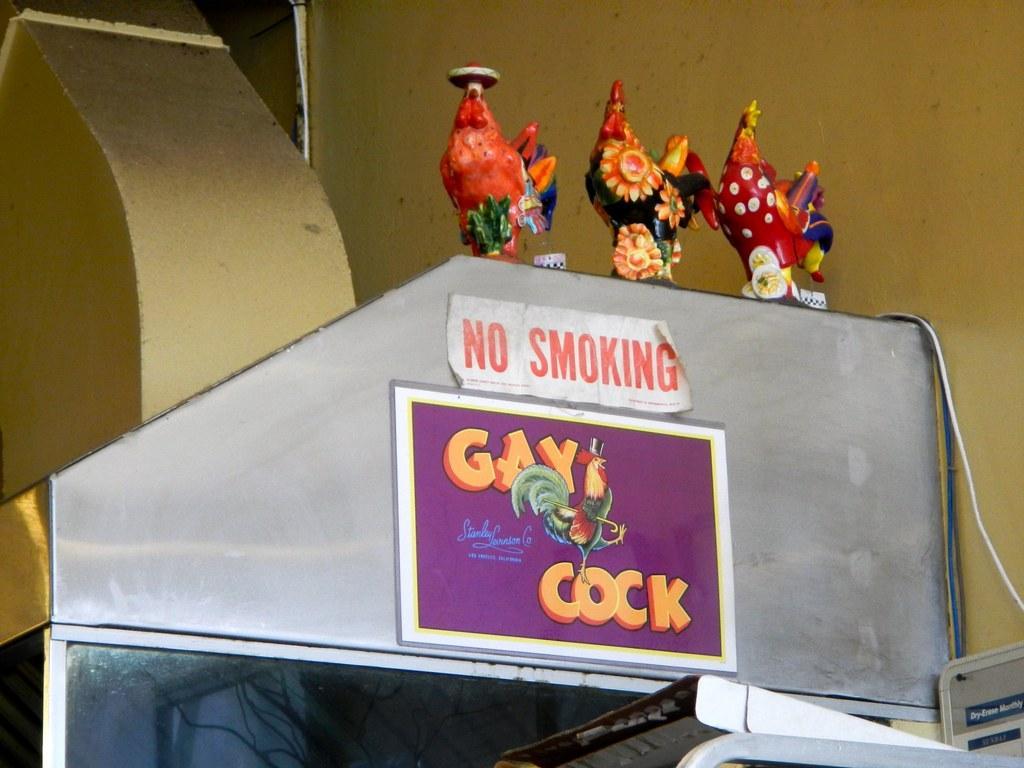Describe this image in one or two sentences. In this picture we can see show pieces, and a few things on an object. We can see some objects in the bottom right. A wire and a wall is visible in the background. 